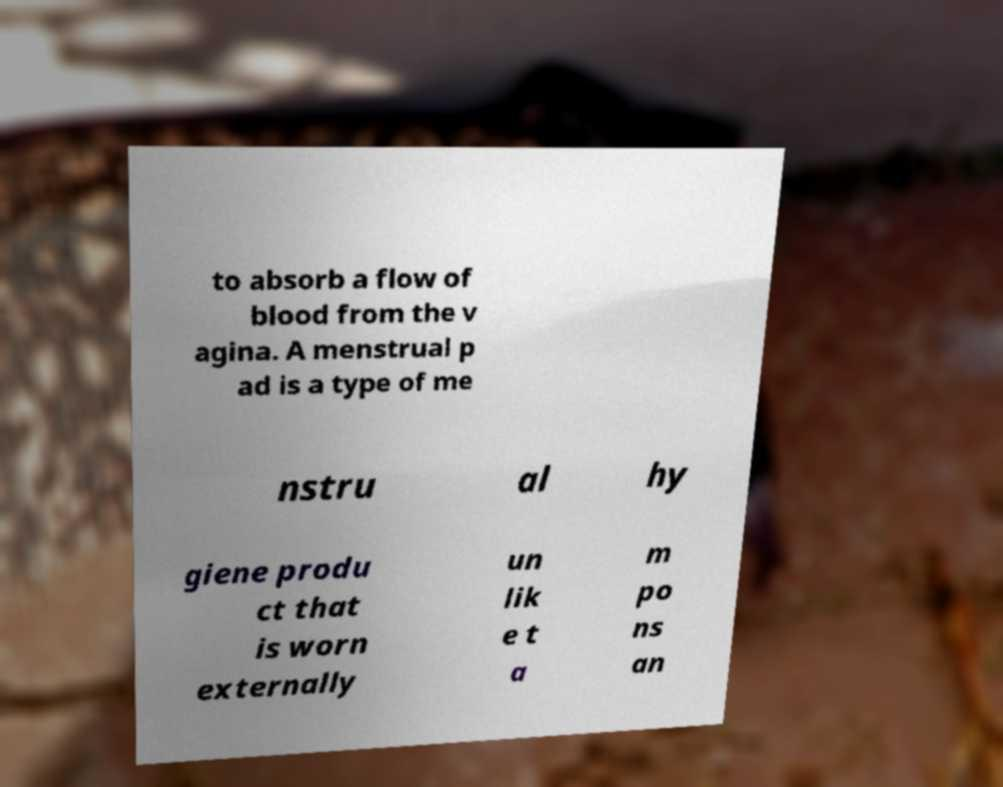For documentation purposes, I need the text within this image transcribed. Could you provide that? to absorb a flow of blood from the v agina. A menstrual p ad is a type of me nstru al hy giene produ ct that is worn externally un lik e t a m po ns an 